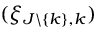<formula> <loc_0><loc_0><loc_500><loc_500>( \xi _ { J \ \{ k \} , k } )</formula> 